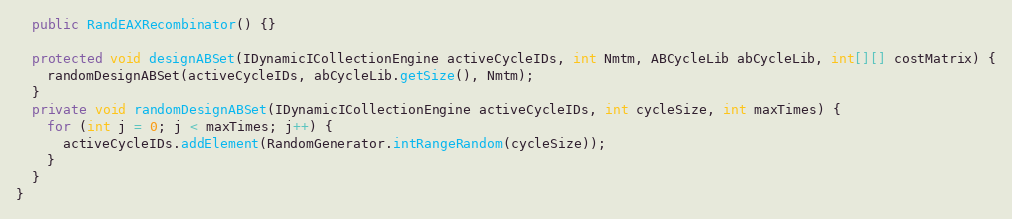<code> <loc_0><loc_0><loc_500><loc_500><_Java_>
  public RandEAXRecombinator() {}

  protected void designABSet(IDynamicICollectionEngine activeCycleIDs, int Nmtm, ABCycleLib abCycleLib, int[][] costMatrix) {
    randomDesignABSet(activeCycleIDs, abCycleLib.getSize(), Nmtm);
  }
  private void randomDesignABSet(IDynamicICollectionEngine activeCycleIDs, int cycleSize, int maxTimes) {
    for (int j = 0; j < maxTimes; j++) {
      activeCycleIDs.addElement(RandomGenerator.intRangeRandom(cycleSize));
    }
  }
}
</code> 